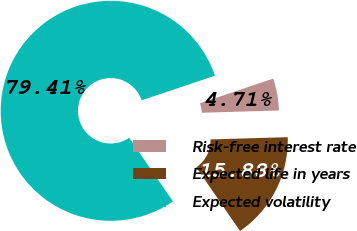Convert chart. <chart><loc_0><loc_0><loc_500><loc_500><pie_chart><fcel>Risk-free interest rate<fcel>Expected life in years<fcel>Expected volatility<nl><fcel>4.71%<fcel>15.88%<fcel>79.41%<nl></chart> 